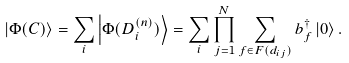Convert formula to latex. <formula><loc_0><loc_0><loc_500><loc_500>\left | \Phi ( C ) \right \rangle = \sum _ { i } \left | \Phi ( D ^ { ( n ) } _ { i } ) \right \rangle = \sum _ { i } \prod _ { j = 1 } ^ { N } \sum _ { f \in F ( d _ { i j } ) } b _ { f } ^ { \dagger } \left | 0 \right \rangle .</formula> 